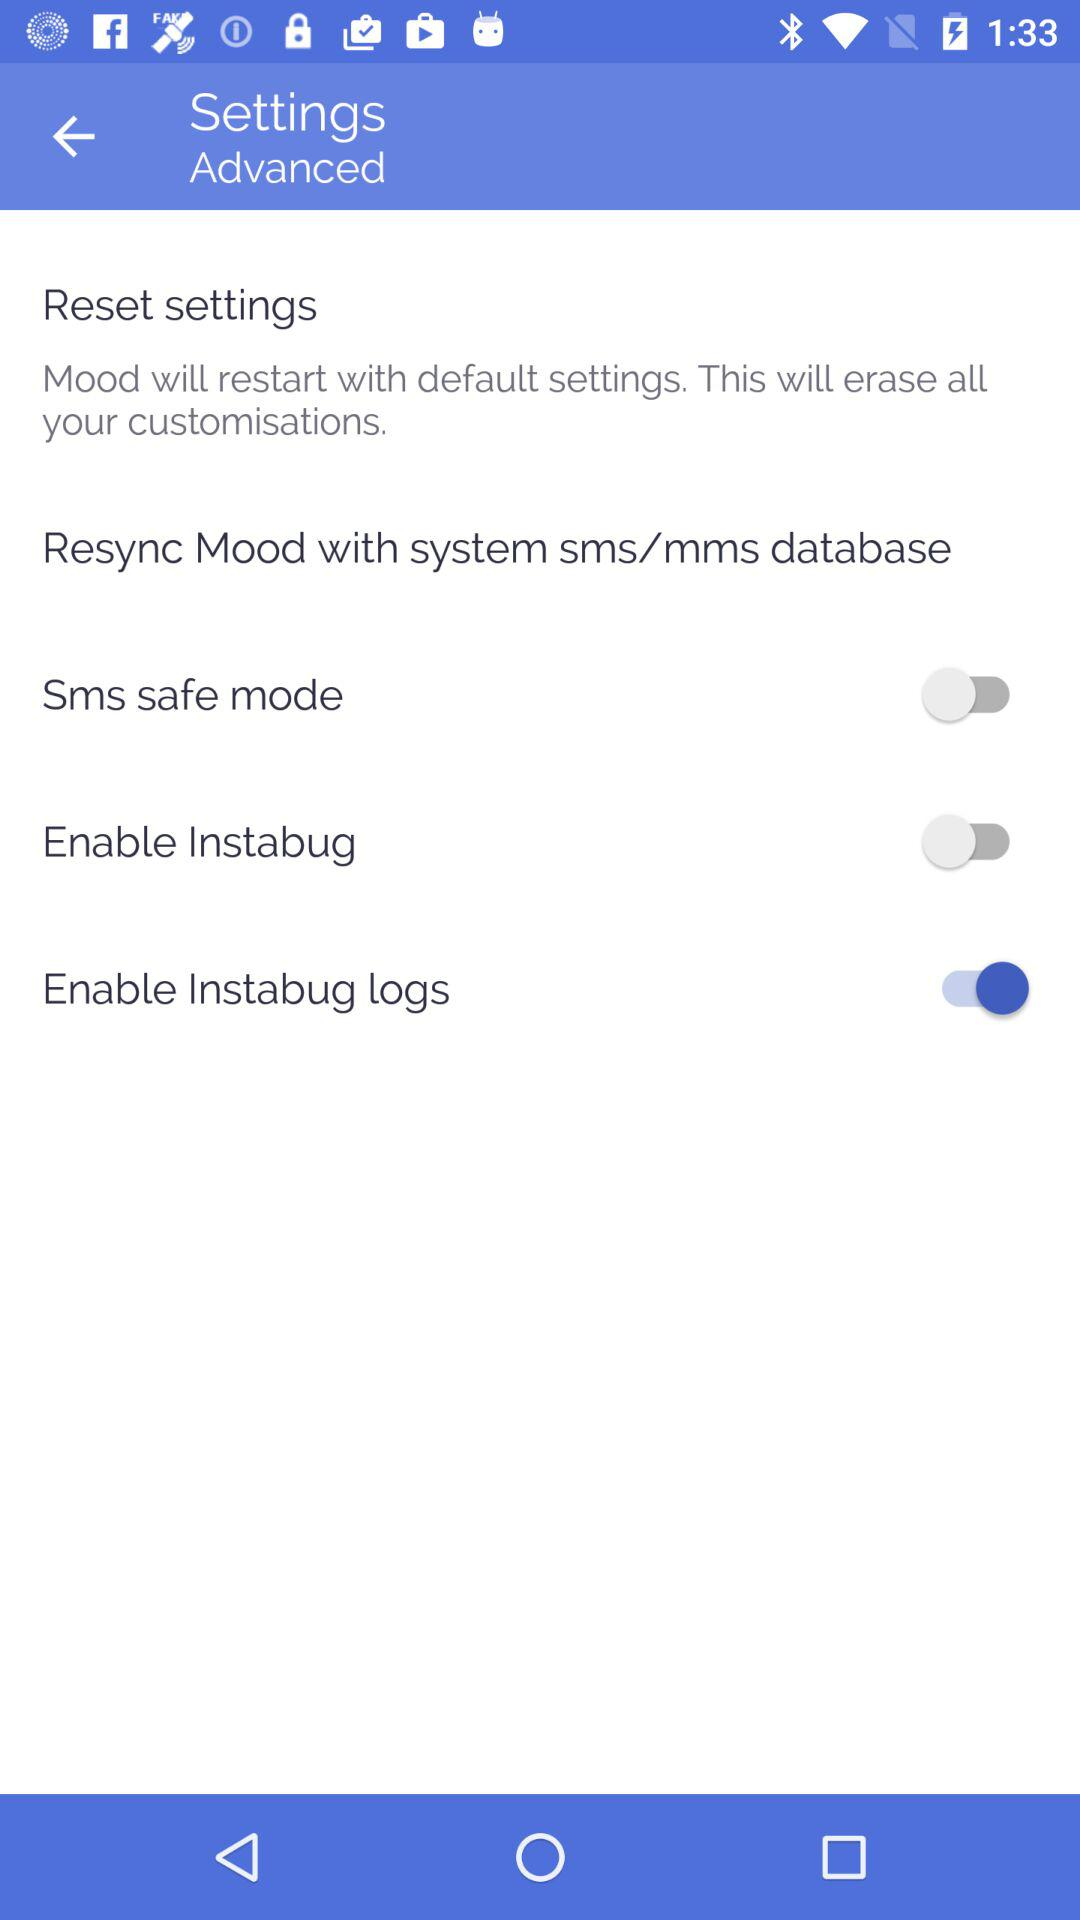What is the status of "Enable Instabug"? The status of "Enable Instabug" is "off". 